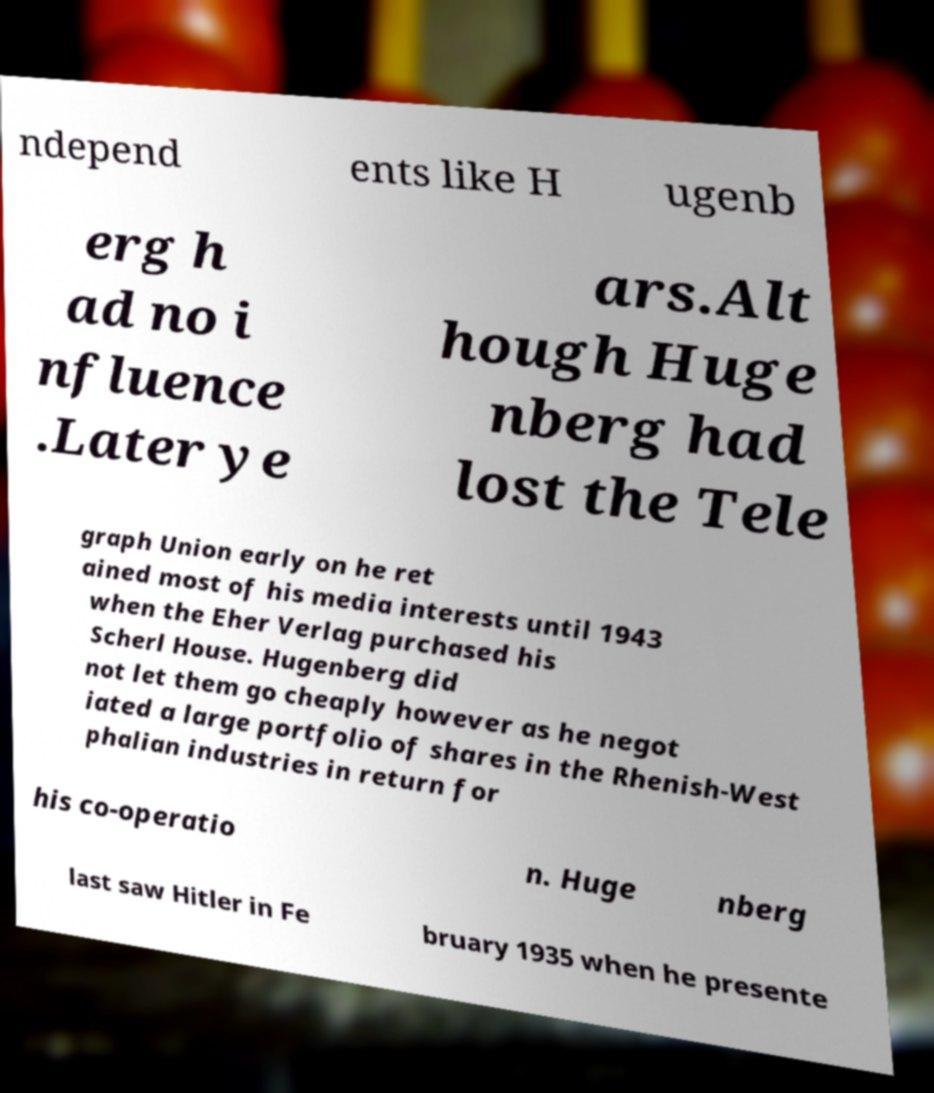Can you accurately transcribe the text from the provided image for me? ndepend ents like H ugenb erg h ad no i nfluence .Later ye ars.Alt hough Huge nberg had lost the Tele graph Union early on he ret ained most of his media interests until 1943 when the Eher Verlag purchased his Scherl House. Hugenberg did not let them go cheaply however as he negot iated a large portfolio of shares in the Rhenish-West phalian industries in return for his co-operatio n. Huge nberg last saw Hitler in Fe bruary 1935 when he presente 